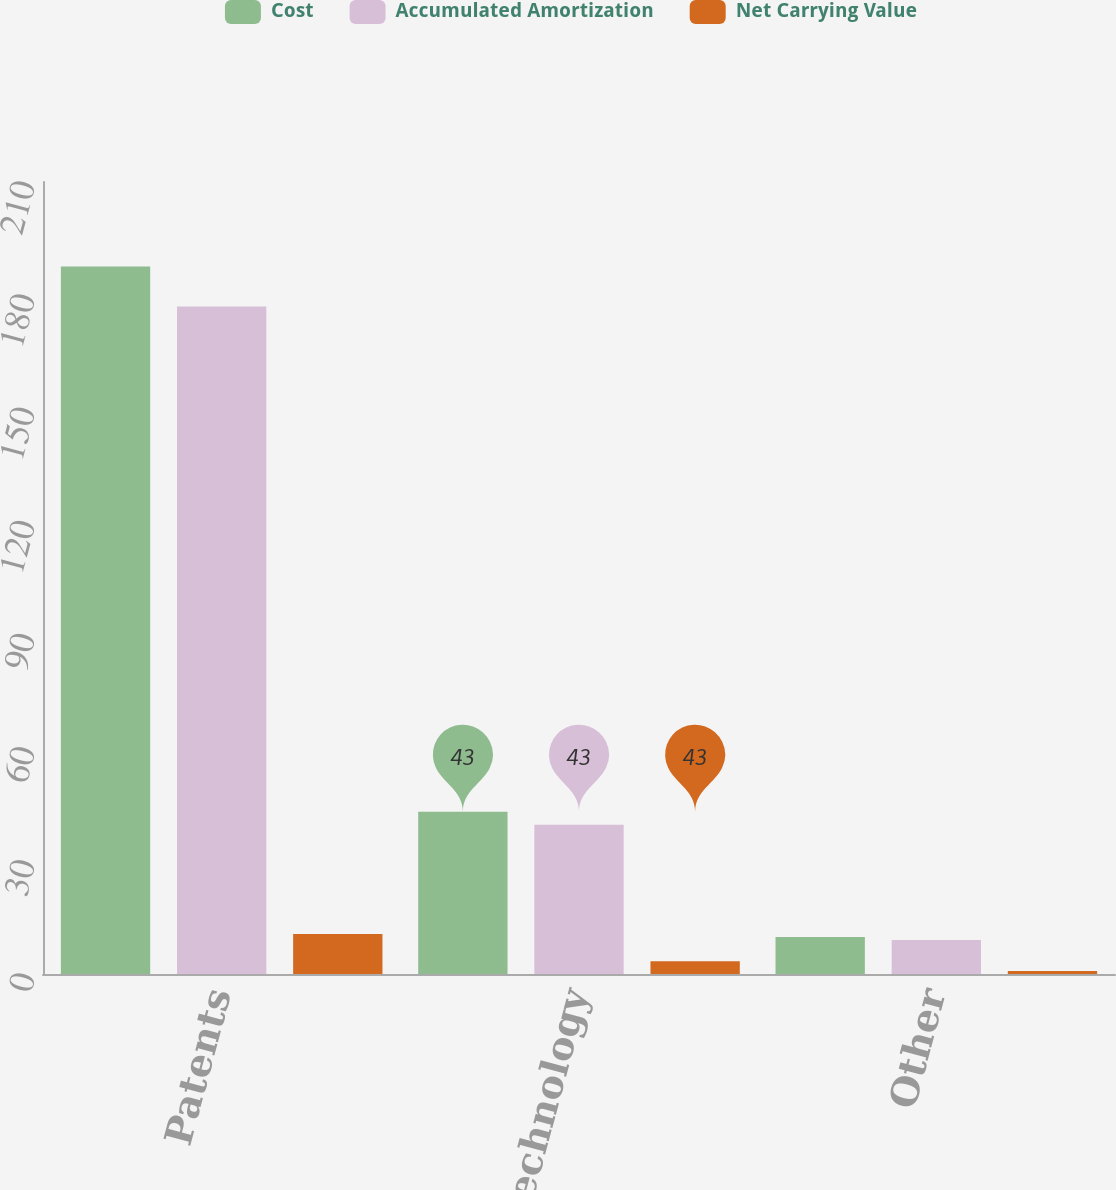Convert chart. <chart><loc_0><loc_0><loc_500><loc_500><stacked_bar_chart><ecel><fcel>Patents<fcel>Developed technology<fcel>Other<nl><fcel>Cost<fcel>187.6<fcel>43<fcel>9.8<nl><fcel>Accumulated Amortization<fcel>177<fcel>39.6<fcel>9<nl><fcel>Net Carrying Value<fcel>10.6<fcel>3.4<fcel>0.8<nl></chart> 